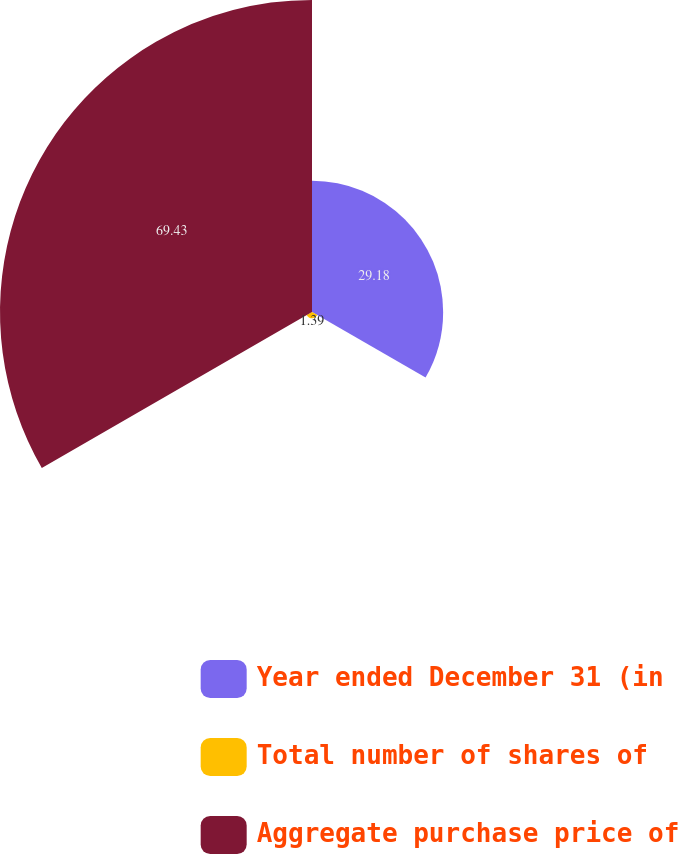<chart> <loc_0><loc_0><loc_500><loc_500><pie_chart><fcel>Year ended December 31 (in<fcel>Total number of shares of<fcel>Aggregate purchase price of<nl><fcel>29.18%<fcel>1.39%<fcel>69.42%<nl></chart> 